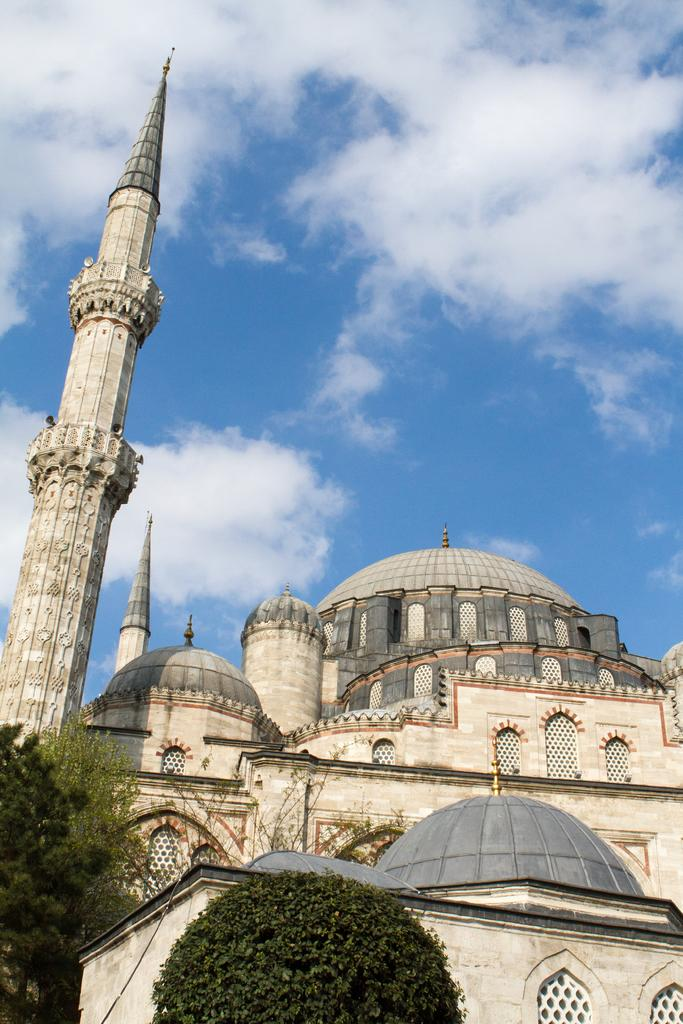What type of building is in the picture? There is a mosque in the picture. What can be seen at the bottom of the picture? There are trees at the bottom of the picture. What is visible at the top of the picture? The sky is visible at the top of the picture. What can be observed in the sky? Clouds are present in the sky. What type of lip can be seen on the mosque in the image? There is no lip present on the mosque in the image. What substance is being used to create the clouds in the image? The clouds in the image are natural formations and do not involve any substances being used. 